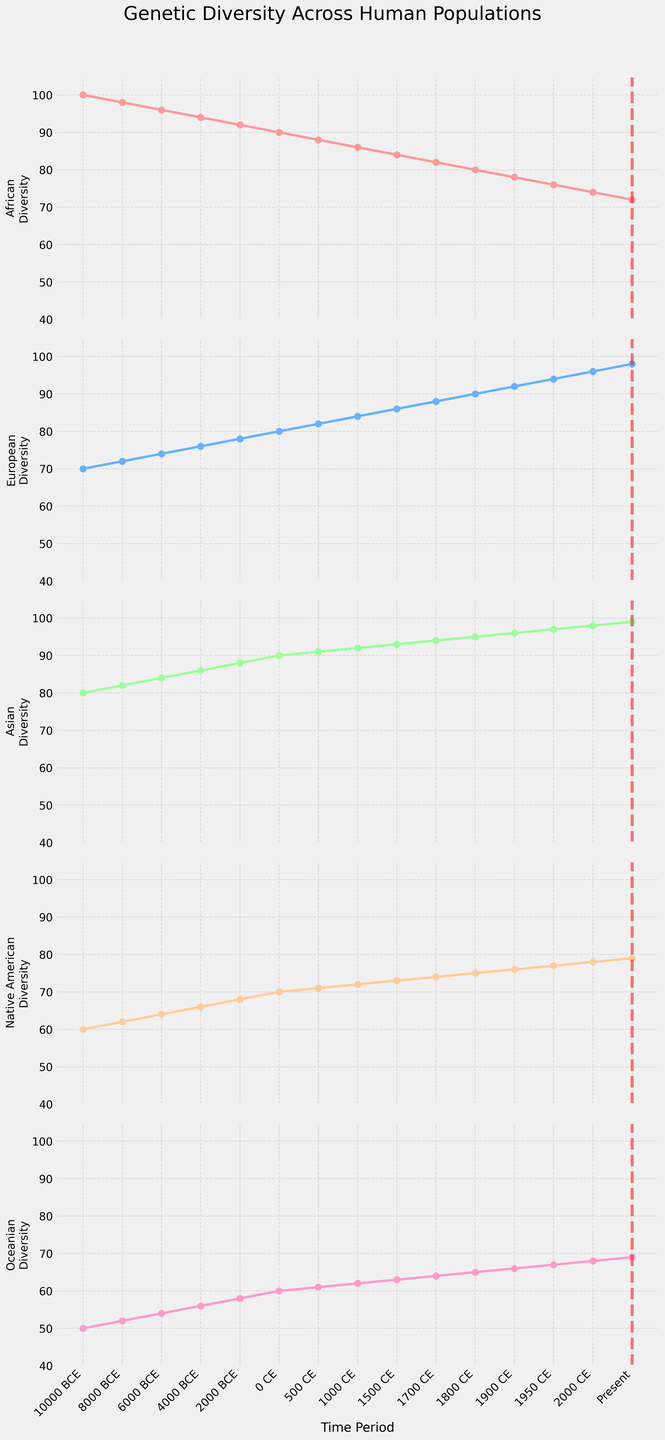What trend can be observed in the genetic diversity of the European population from 10000 BCE to the present? The genetic diversity of the European population shows a steady increase over time, starting from 70 in 10000 BCE and reaching 98 in the present.
Answer: A steady increase Between which two time periods does the African genetic diversity experience the largest decrease? By examining the plot for the African population, the largest decrease occurs between 2000 BCE (92) and the present (72), a difference of 20.
Answer: 2000 BCE and present Which population shows the most consistent increase in genetic diversity over time? The Asian population has a consistent increase in genetic diversity, starting from 80 in 10000 BCE and reaching 99 in the present with no decreases.
Answer: Asian At which time period does Native American genetic diversity reach 75? By looking at the plot for Native American genetic diversity, it reaches 75 around the 1800 CE time period.
Answer: 1800 CE Compare the genetic diversity between the Native American and Oceanian populations in the present time period. Observing the present time period on the plots, the Native American genetic diversity is 79, while the Oceanian genetic diversity is 69.
Answer: Native American: 79 and Oceanian: 69 What is the difference in genetic diversity between the African and European populations in 0 CE? In 0 CE, the African diversity is 90 and the European diversity is 80. The difference is 90 - 80 = 10.
Answer: 10 Which population has the lowest genetic diversity in 10000 BCE and how much is it? The Oceanian population has the lowest genetic diversity in 10000 BCE with a value of 50.
Answer: Oceanian with 50 Calculate the average genetic diversity of the European population across all time periods. Adding the European diversity values and dividing by the number of time periods (15), (70 + 72 + 74 + 76 + 78 + 80 + 82 + 84 + 86 + 88 + 90 + 92 + 94 + 96 + 98) = 1220, hence the average is 1220 / 15 ≈ 81.33.
Answer: 81.33 How does the genetic diversity of the Native American population in 500 CE compare to the genetic diversity of the Oceanian population in 1500 CE? In 500 CE, the Native American diversity is 71. In 1500 CE, the Oceanian diversity is 63. Thus, 71 - 63 = 8, showing the Native American diversity is higher by 8.
Answer: 8 higher 